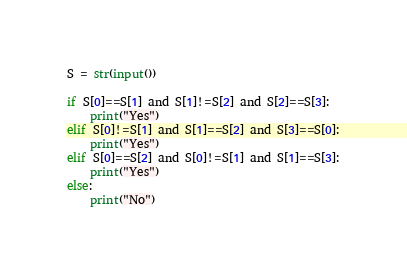<code> <loc_0><loc_0><loc_500><loc_500><_Python_>S = str(input())

if S[0]==S[1] and S[1]!=S[2] and S[2]==S[3]:
    print("Yes")
elif S[0]!=S[1] and S[1]==S[2] and S[3]==S[0]:
    print("Yes")
elif S[0]==S[2] and S[0]!=S[1] and S[1]==S[3]:
    print("Yes")
else:
    print("No")</code> 